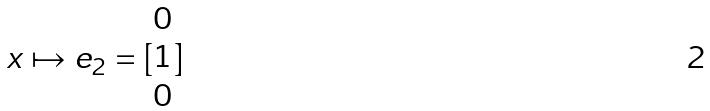<formula> <loc_0><loc_0><loc_500><loc_500>x \mapsto e _ { 2 } = [ \begin{matrix} 0 \\ 1 \\ 0 \end{matrix} ]</formula> 